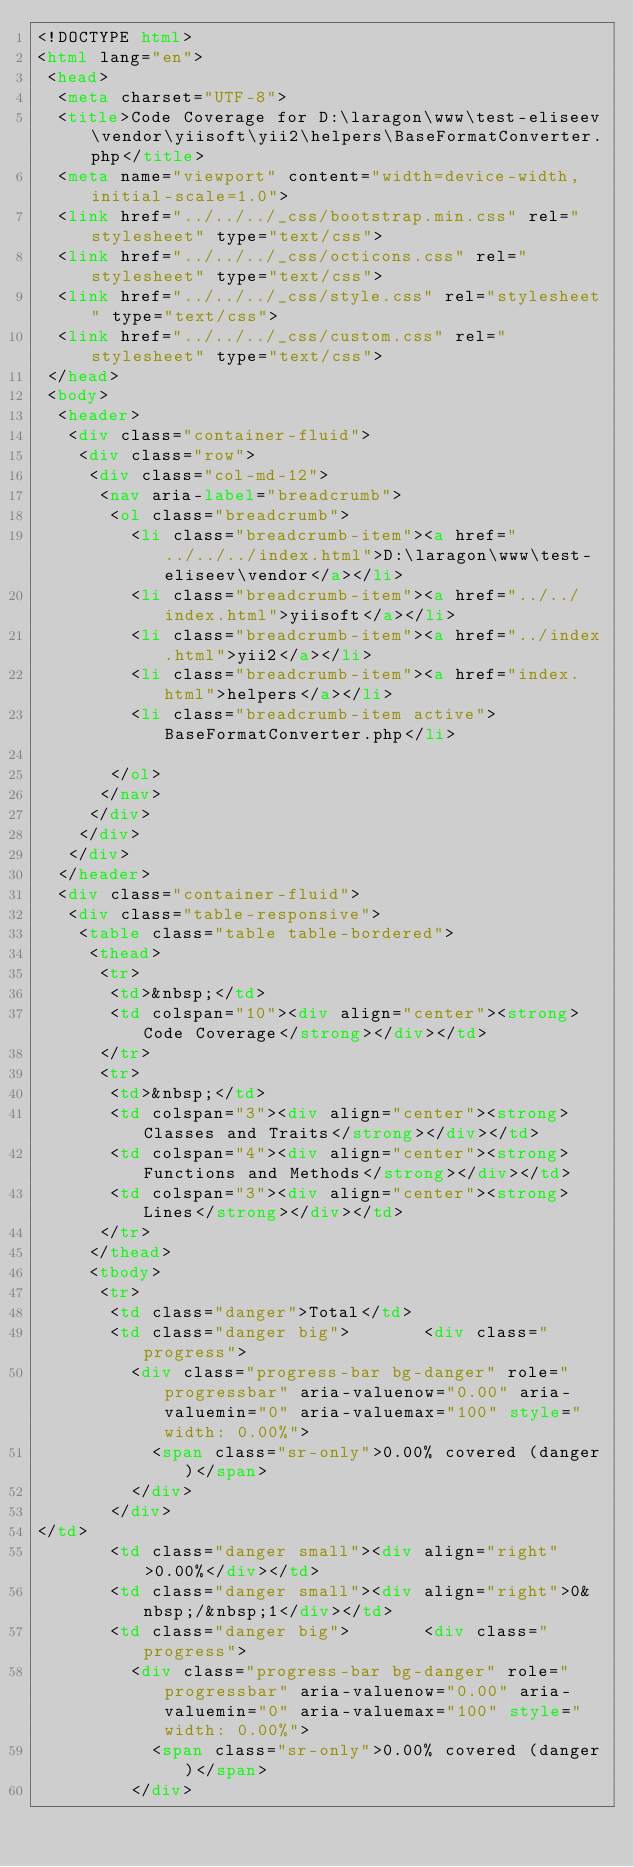Convert code to text. <code><loc_0><loc_0><loc_500><loc_500><_HTML_><!DOCTYPE html>
<html lang="en">
 <head>
  <meta charset="UTF-8">
  <title>Code Coverage for D:\laragon\www\test-eliseev\vendor\yiisoft\yii2\helpers\BaseFormatConverter.php</title>
  <meta name="viewport" content="width=device-width, initial-scale=1.0">
  <link href="../../../_css/bootstrap.min.css" rel="stylesheet" type="text/css">
  <link href="../../../_css/octicons.css" rel="stylesheet" type="text/css">
  <link href="../../../_css/style.css" rel="stylesheet" type="text/css">
  <link href="../../../_css/custom.css" rel="stylesheet" type="text/css">
 </head>
 <body>
  <header>
   <div class="container-fluid">
    <div class="row">
     <div class="col-md-12">
      <nav aria-label="breadcrumb">
       <ol class="breadcrumb">
         <li class="breadcrumb-item"><a href="../../../index.html">D:\laragon\www\test-eliseev\vendor</a></li>
         <li class="breadcrumb-item"><a href="../../index.html">yiisoft</a></li>
         <li class="breadcrumb-item"><a href="../index.html">yii2</a></li>
         <li class="breadcrumb-item"><a href="index.html">helpers</a></li>
         <li class="breadcrumb-item active">BaseFormatConverter.php</li>

       </ol>
      </nav>
     </div>
    </div>
   </div>
  </header>
  <div class="container-fluid">
   <div class="table-responsive">
    <table class="table table-bordered">
     <thead>
      <tr>
       <td>&nbsp;</td>
       <td colspan="10"><div align="center"><strong>Code Coverage</strong></div></td>
      </tr>
      <tr>
       <td>&nbsp;</td>
       <td colspan="3"><div align="center"><strong>Classes and Traits</strong></div></td>
       <td colspan="4"><div align="center"><strong>Functions and Methods</strong></div></td>
       <td colspan="3"><div align="center"><strong>Lines</strong></div></td>
      </tr>
     </thead>
     <tbody>
      <tr>
       <td class="danger">Total</td>
       <td class="danger big">       <div class="progress">
         <div class="progress-bar bg-danger" role="progressbar" aria-valuenow="0.00" aria-valuemin="0" aria-valuemax="100" style="width: 0.00%">
           <span class="sr-only">0.00% covered (danger)</span>
         </div>
       </div>
</td>
       <td class="danger small"><div align="right">0.00%</div></td>
       <td class="danger small"><div align="right">0&nbsp;/&nbsp;1</div></td>
       <td class="danger big">       <div class="progress">
         <div class="progress-bar bg-danger" role="progressbar" aria-valuenow="0.00" aria-valuemin="0" aria-valuemax="100" style="width: 0.00%">
           <span class="sr-only">0.00% covered (danger)</span>
         </div></code> 